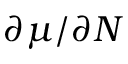Convert formula to latex. <formula><loc_0><loc_0><loc_500><loc_500>\partial \mu / \partial N</formula> 